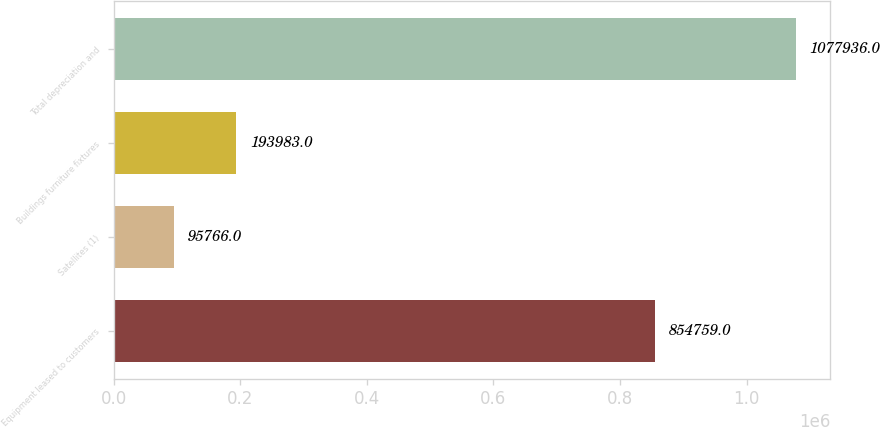<chart> <loc_0><loc_0><loc_500><loc_500><bar_chart><fcel>Equipment leased to customers<fcel>Satellites (1)<fcel>Buildings furniture fixtures<fcel>Total depreciation and<nl><fcel>854759<fcel>95766<fcel>193983<fcel>1.07794e+06<nl></chart> 